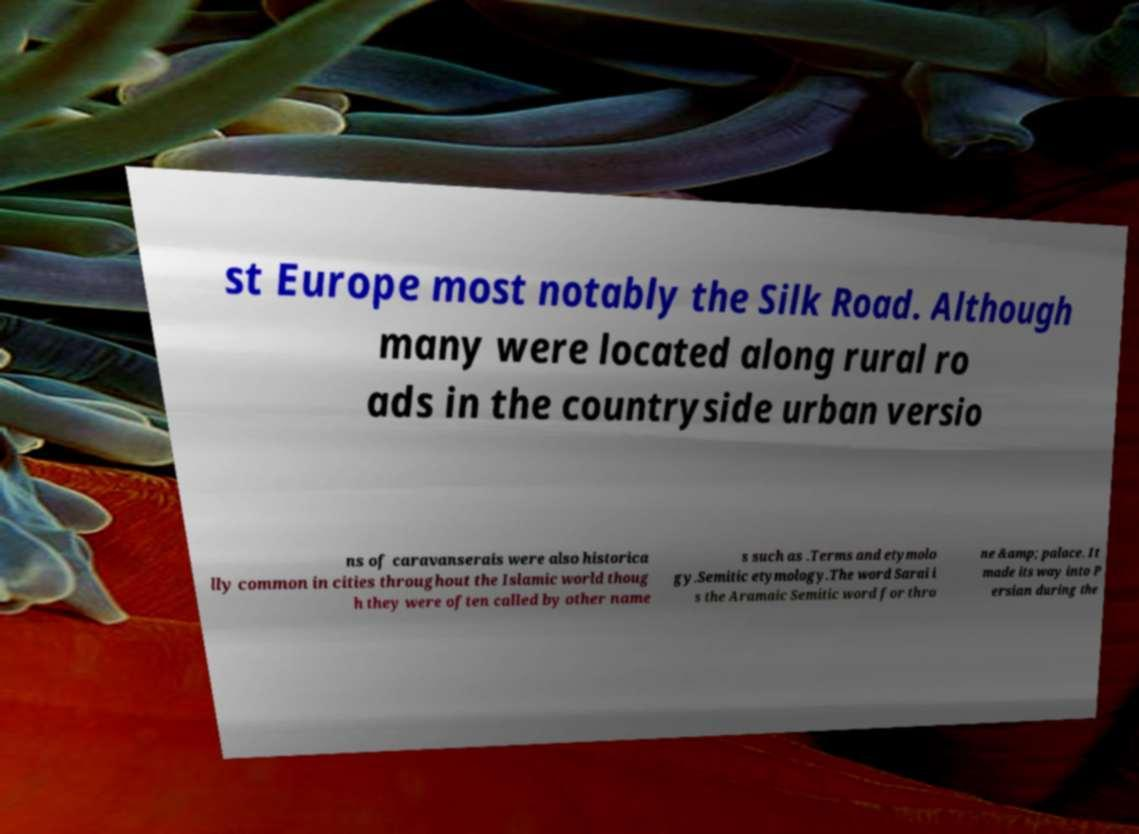For documentation purposes, I need the text within this image transcribed. Could you provide that? st Europe most notably the Silk Road. Although many were located along rural ro ads in the countryside urban versio ns of caravanserais were also historica lly common in cities throughout the Islamic world thoug h they were often called by other name s such as .Terms and etymolo gy.Semitic etymology.The word Sarai i s the Aramaic Semitic word for thro ne &amp; palace. It made its way into P ersian during the 